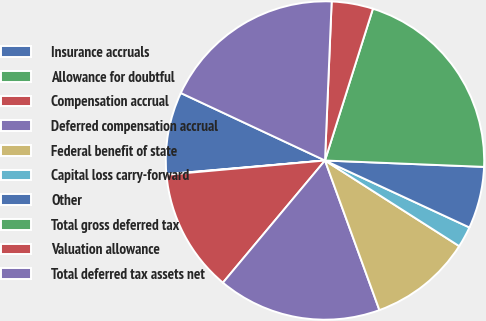<chart> <loc_0><loc_0><loc_500><loc_500><pie_chart><fcel>Insurance accruals<fcel>Allowance for doubtful<fcel>Compensation accrual<fcel>Deferred compensation accrual<fcel>Federal benefit of state<fcel>Capital loss carry-forward<fcel>Other<fcel>Total gross deferred tax<fcel>Valuation allowance<fcel>Total deferred tax assets net<nl><fcel>8.34%<fcel>0.06%<fcel>12.49%<fcel>16.63%<fcel>10.41%<fcel>2.13%<fcel>6.27%<fcel>20.77%<fcel>4.2%<fcel>18.7%<nl></chart> 